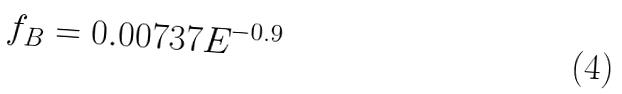Convert formula to latex. <formula><loc_0><loc_0><loc_500><loc_500>f _ { B } = 0 . 0 0 7 3 7 E ^ { - 0 . 9 }</formula> 